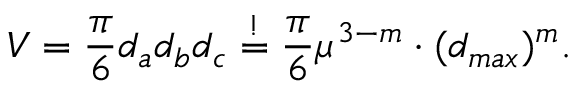Convert formula to latex. <formula><loc_0><loc_0><loc_500><loc_500>V = \frac { \pi } { 6 } d _ { a } d _ { b } d _ { c } \overset { ! } { = } \frac { \pi } { 6 } \mu ^ { 3 - m } \cdot ( d _ { \max } ) ^ { m } .</formula> 